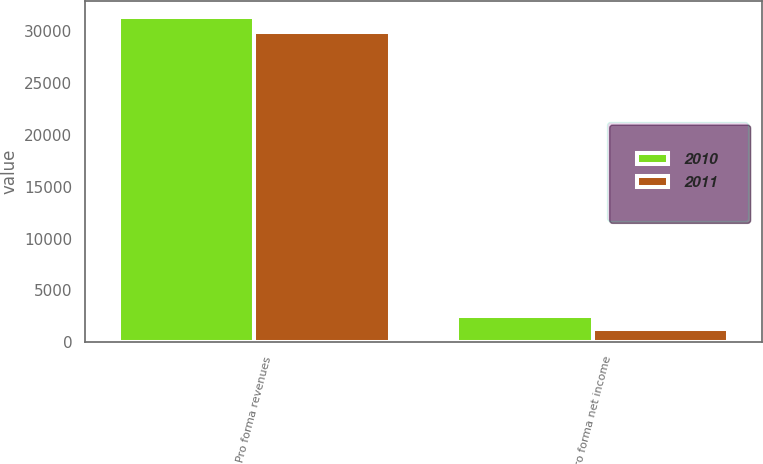<chart> <loc_0><loc_0><loc_500><loc_500><stacked_bar_chart><ecel><fcel>Pro forma revenues<fcel>Pro forma net income<nl><fcel>2010<fcel>31383<fcel>2507<nl><fcel>2011<fcel>29925<fcel>1257<nl></chart> 